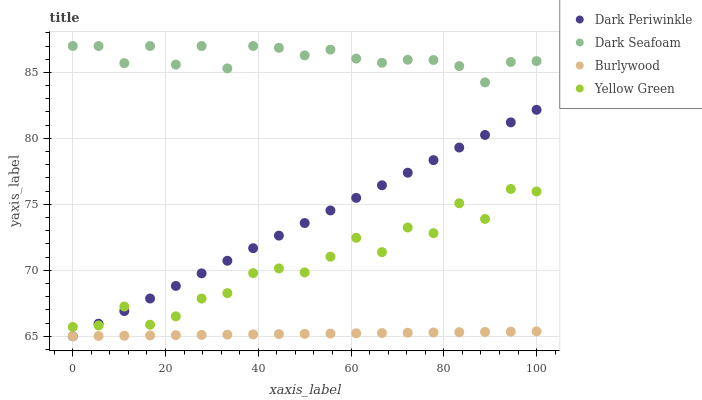Does Burlywood have the minimum area under the curve?
Answer yes or no. Yes. Does Dark Seafoam have the maximum area under the curve?
Answer yes or no. Yes. Does Dark Periwinkle have the minimum area under the curve?
Answer yes or no. No. Does Dark Periwinkle have the maximum area under the curve?
Answer yes or no. No. Is Burlywood the smoothest?
Answer yes or no. Yes. Is Yellow Green the roughest?
Answer yes or no. Yes. Is Dark Seafoam the smoothest?
Answer yes or no. No. Is Dark Seafoam the roughest?
Answer yes or no. No. Does Burlywood have the lowest value?
Answer yes or no. Yes. Does Dark Seafoam have the lowest value?
Answer yes or no. No. Does Dark Seafoam have the highest value?
Answer yes or no. Yes. Does Dark Periwinkle have the highest value?
Answer yes or no. No. Is Burlywood less than Dark Seafoam?
Answer yes or no. Yes. Is Yellow Green greater than Burlywood?
Answer yes or no. Yes. Does Dark Periwinkle intersect Yellow Green?
Answer yes or no. Yes. Is Dark Periwinkle less than Yellow Green?
Answer yes or no. No. Is Dark Periwinkle greater than Yellow Green?
Answer yes or no. No. Does Burlywood intersect Dark Seafoam?
Answer yes or no. No. 